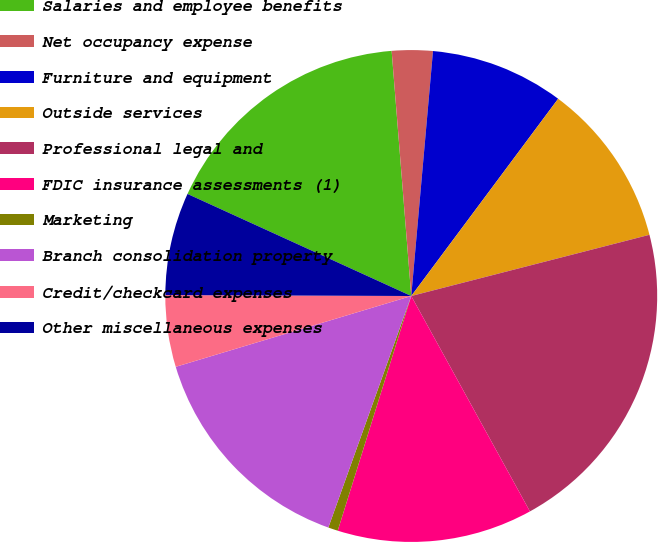Convert chart to OTSL. <chart><loc_0><loc_0><loc_500><loc_500><pie_chart><fcel>Salaries and employee benefits<fcel>Net occupancy expense<fcel>Furniture and equipment<fcel>Outside services<fcel>Professional legal and<fcel>FDIC insurance assessments (1)<fcel>Marketing<fcel>Branch consolidation property<fcel>Credit/checkcard expenses<fcel>Other miscellaneous expenses<nl><fcel>16.92%<fcel>2.68%<fcel>8.78%<fcel>10.81%<fcel>20.99%<fcel>12.85%<fcel>0.64%<fcel>14.88%<fcel>4.71%<fcel>6.75%<nl></chart> 